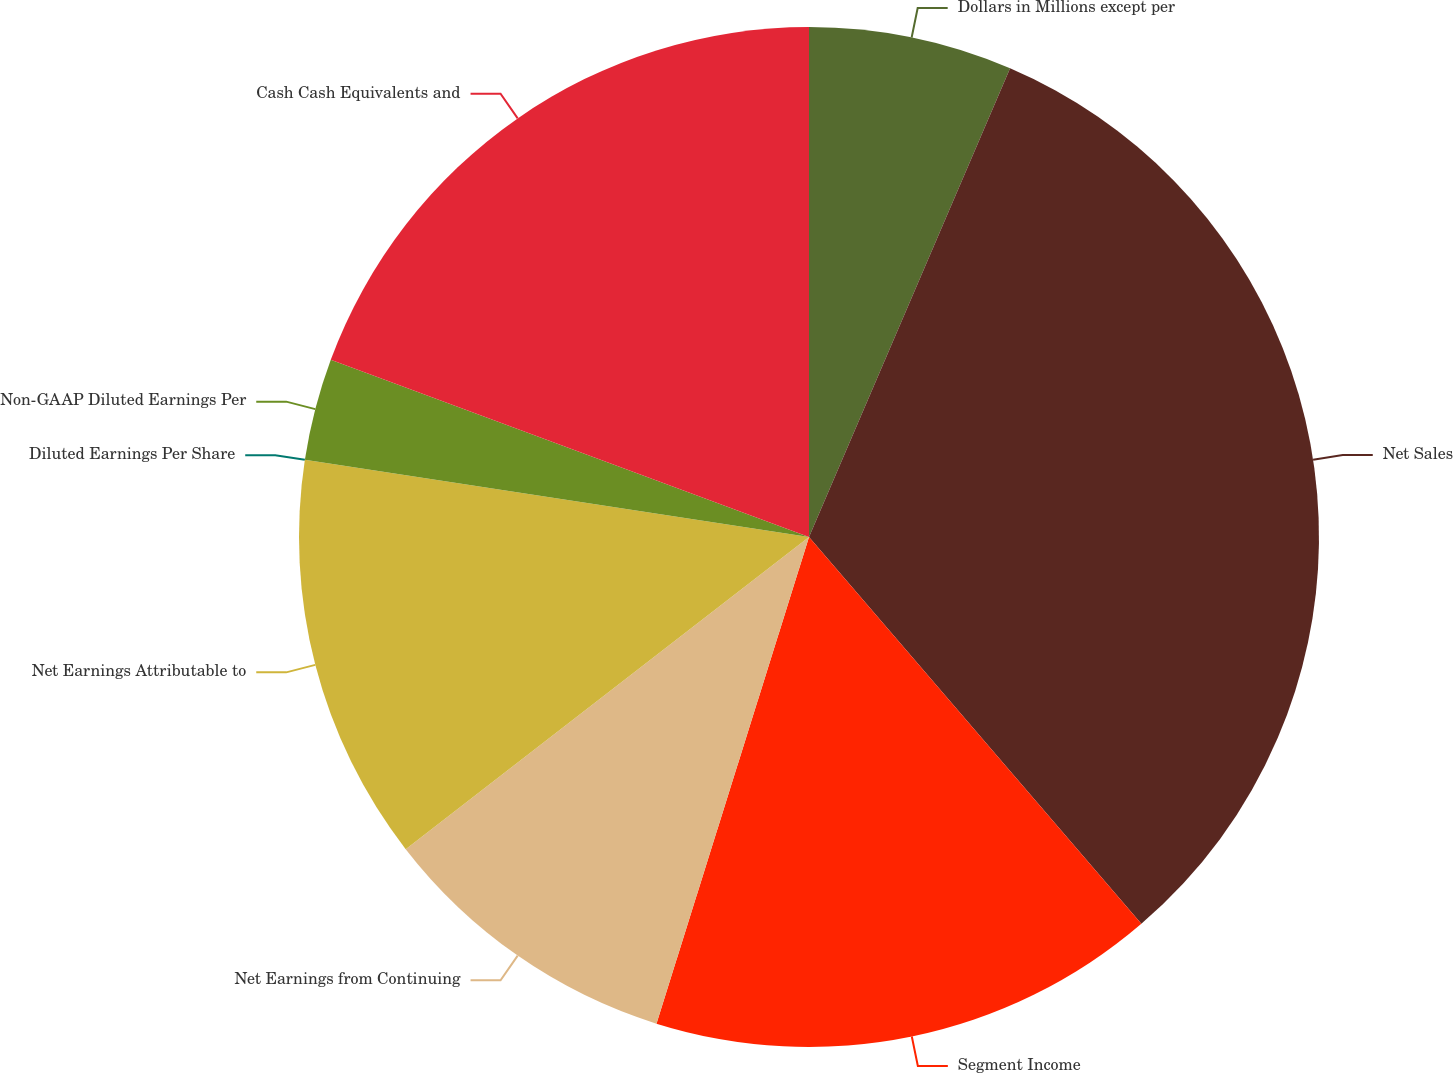<chart> <loc_0><loc_0><loc_500><loc_500><pie_chart><fcel>Dollars in Millions except per<fcel>Net Sales<fcel>Segment Income<fcel>Net Earnings from Continuing<fcel>Net Earnings Attributable to<fcel>Diluted Earnings Per Share<fcel>Non-GAAP Diluted Earnings Per<fcel>Cash Cash Equivalents and<nl><fcel>6.45%<fcel>32.25%<fcel>16.13%<fcel>9.68%<fcel>12.9%<fcel>0.0%<fcel>3.23%<fcel>19.35%<nl></chart> 